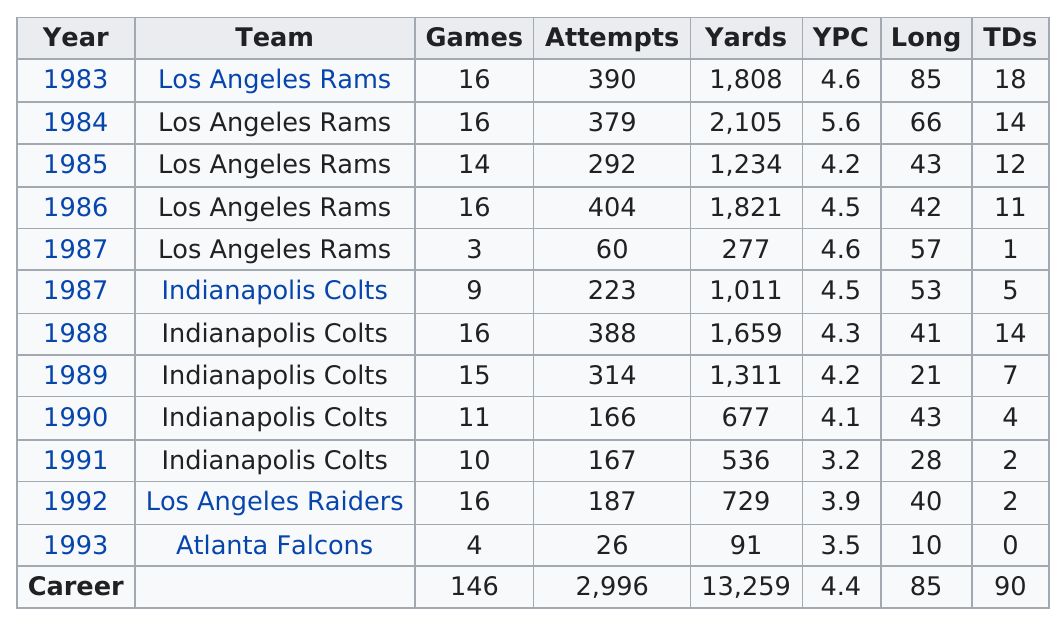Outline some significant characteristics in this image. In the year 1984, Emmitt Smith, also known as "Emmitt Ice," earned the most rushing yards with a total of 1,553 yards. In the 1988 season, John Riggins, more commonly known as 'Dickerson,' scored 14 touchdowns. After the player played for the Los Angeles Rams, he went on to play for the Indianapolis Colts. In 1983, did Dickerson score more touchdowns than in 1984? The answer is 1983. Did this player have more than 10 touchdowns in the number of years specified? 5.. 